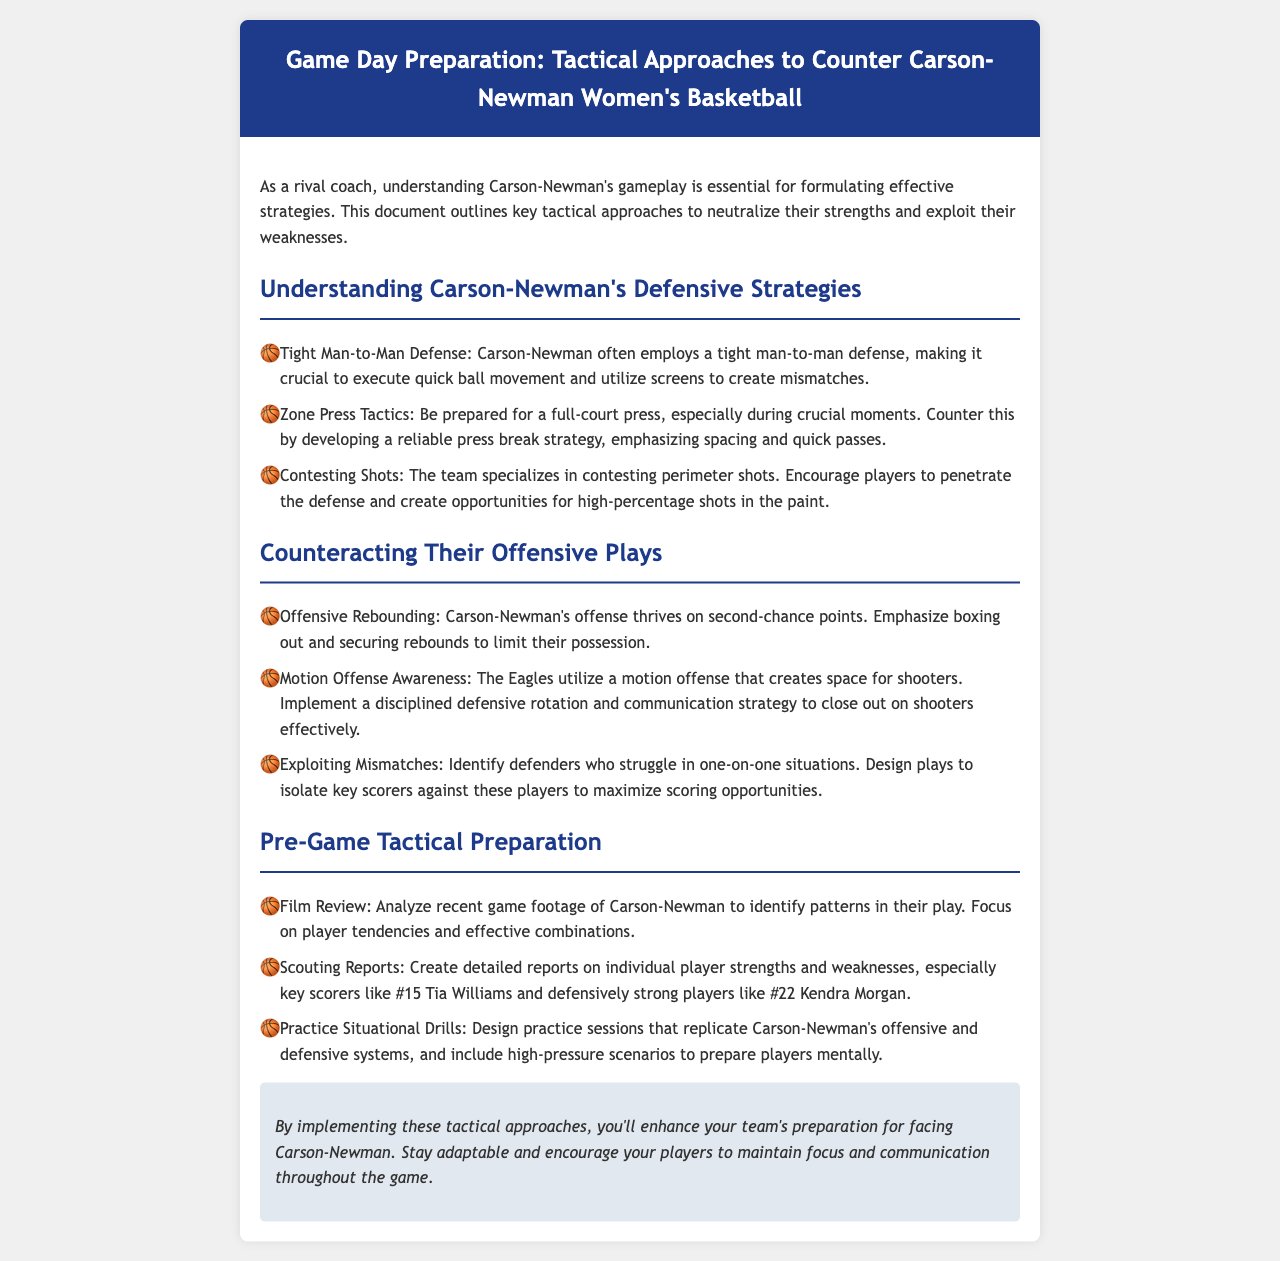What defensive tactic does Carson-Newman often use? The document mentions that Carson-Newman employs a tight man-to-man defense.
Answer: Tight man-to-man defense What should teams emphasize to counter Carson-Newman's offensive rebounding? According to the document, teams should emphasize boxing out and securing rebounds.
Answer: Boxing out Which player is highlighted as a key scorer for Carson-Newman? The document identifies #15 Tia Williams as a key scorer.
Answer: #15 Tia Williams What tactical preparation involves reviewing video footage? The document refers to film review as part of the pre-game tactical preparation.
Answer: Film Review What type of shots does Carson-Newman specialize in contesting? The document notes that the team specializes in contesting perimeter shots.
Answer: Perimeter shots What should teams develop to counter Carson-Newman's full-court press? The document suggests developing a reliable press break strategy.
Answer: Press break strategy What aspect of defensive tactics is emphasized when facing Carson-Newman's motion offense? The document highlights the importance of a disciplined defensive rotation and communication strategy.
Answer: Defensive rotation and communication In what context should teams include high-pressure scenarios during practice? The document states that situational drills should replicate Carson-Newman's systems and include high-pressure scenarios.
Answer: High-pressure scenarios 